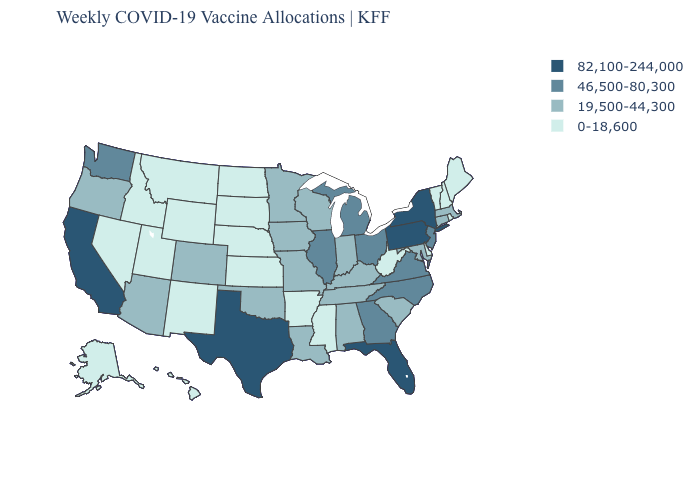Among the states that border Iowa , does Illinois have the highest value?
Quick response, please. Yes. Name the states that have a value in the range 19,500-44,300?
Quick response, please. Alabama, Arizona, Colorado, Connecticut, Indiana, Iowa, Kentucky, Louisiana, Maryland, Massachusetts, Minnesota, Missouri, Oklahoma, Oregon, South Carolina, Tennessee, Wisconsin. Which states have the lowest value in the Northeast?
Keep it brief. Maine, New Hampshire, Rhode Island, Vermont. What is the value of Florida?
Concise answer only. 82,100-244,000. What is the value of Virginia?
Quick response, please. 46,500-80,300. Does California have the highest value in the West?
Concise answer only. Yes. What is the lowest value in the USA?
Be succinct. 0-18,600. Name the states that have a value in the range 0-18,600?
Give a very brief answer. Alaska, Arkansas, Delaware, Hawaii, Idaho, Kansas, Maine, Mississippi, Montana, Nebraska, Nevada, New Hampshire, New Mexico, North Dakota, Rhode Island, South Dakota, Utah, Vermont, West Virginia, Wyoming. Name the states that have a value in the range 19,500-44,300?
Keep it brief. Alabama, Arizona, Colorado, Connecticut, Indiana, Iowa, Kentucky, Louisiana, Maryland, Massachusetts, Minnesota, Missouri, Oklahoma, Oregon, South Carolina, Tennessee, Wisconsin. Among the states that border Tennessee , which have the highest value?
Answer briefly. Georgia, North Carolina, Virginia. What is the lowest value in the MidWest?
Write a very short answer. 0-18,600. Name the states that have a value in the range 82,100-244,000?
Answer briefly. California, Florida, New York, Pennsylvania, Texas. Does the map have missing data?
Answer briefly. No. What is the value of West Virginia?
Write a very short answer. 0-18,600. Which states have the lowest value in the South?
Give a very brief answer. Arkansas, Delaware, Mississippi, West Virginia. 